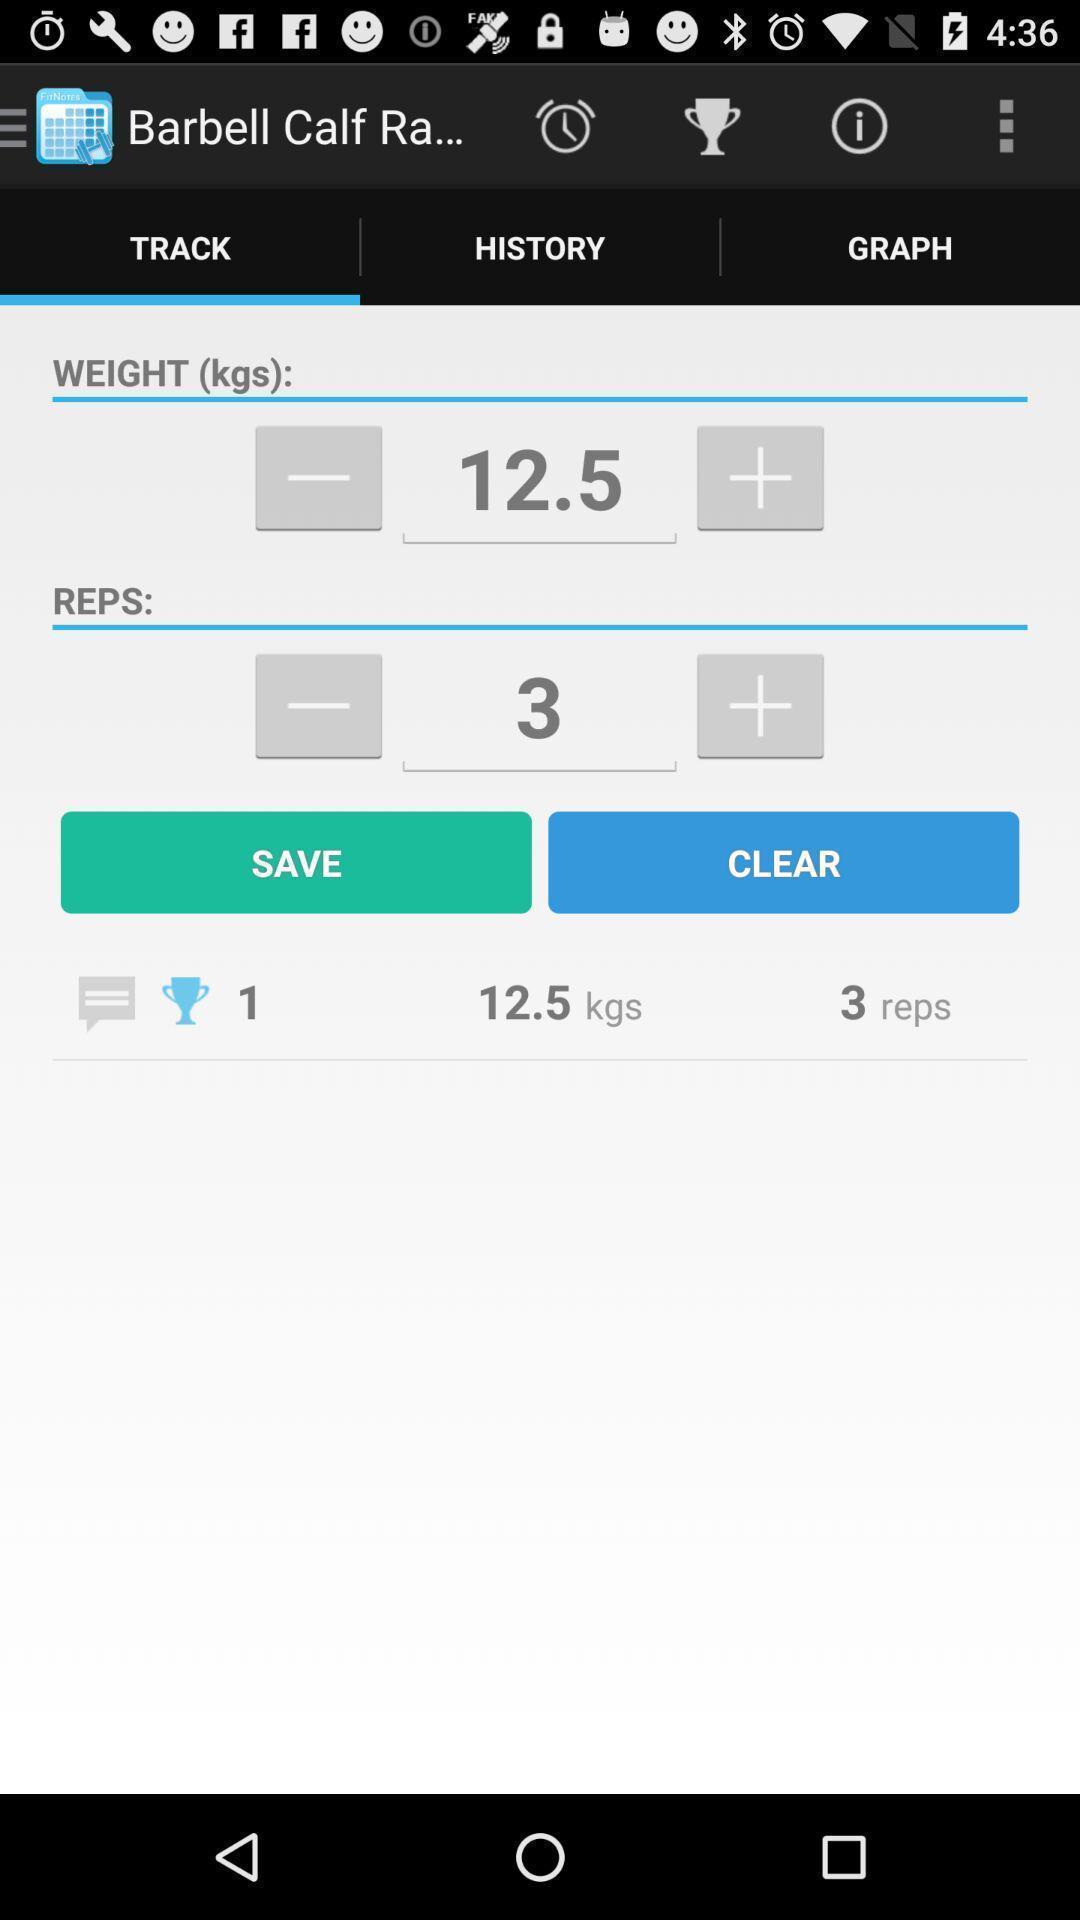Explain the elements present in this screenshot. Page to set work out track in the fitness app. 